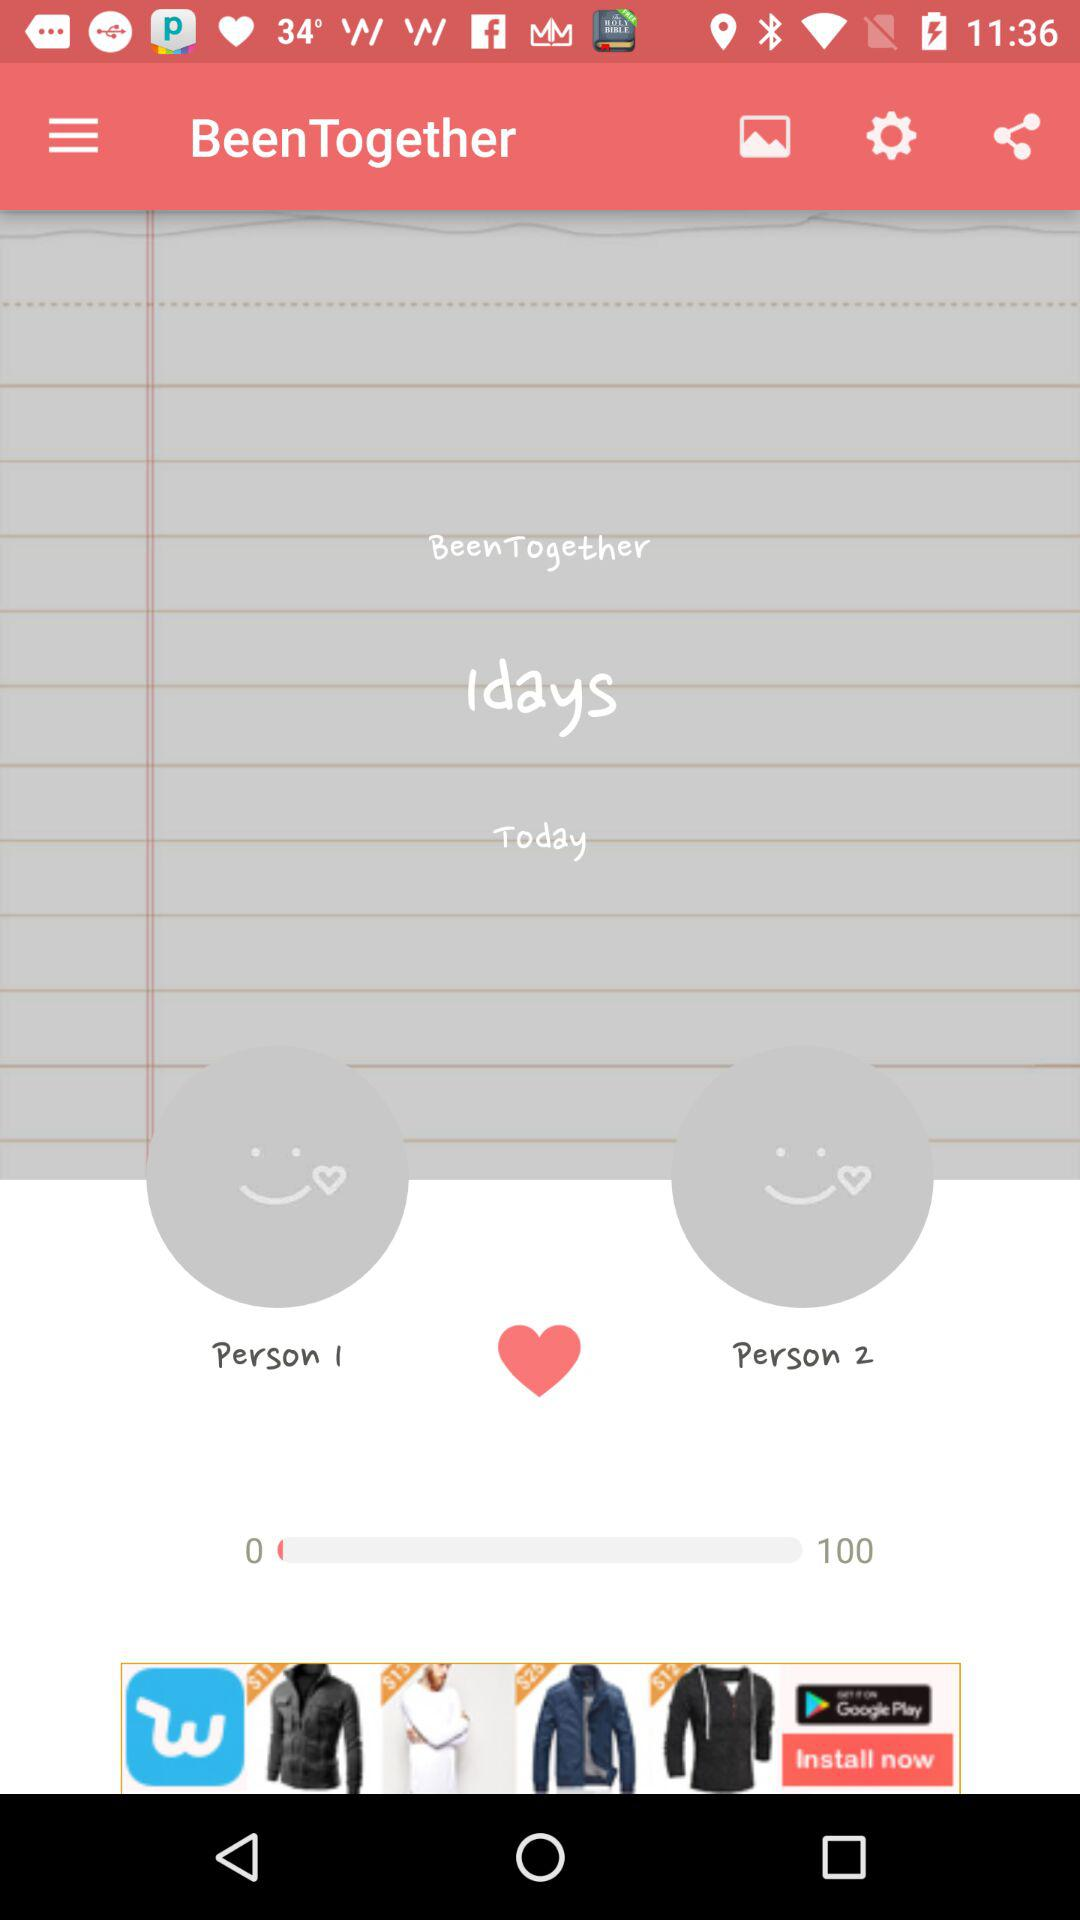What is the total number of days needed to be together? The total number of days is 1. 